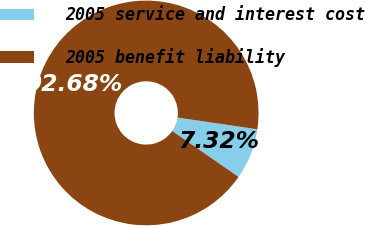Convert chart to OTSL. <chart><loc_0><loc_0><loc_500><loc_500><pie_chart><fcel>2005 service and interest cost<fcel>2005 benefit liability<nl><fcel>7.32%<fcel>92.68%<nl></chart> 